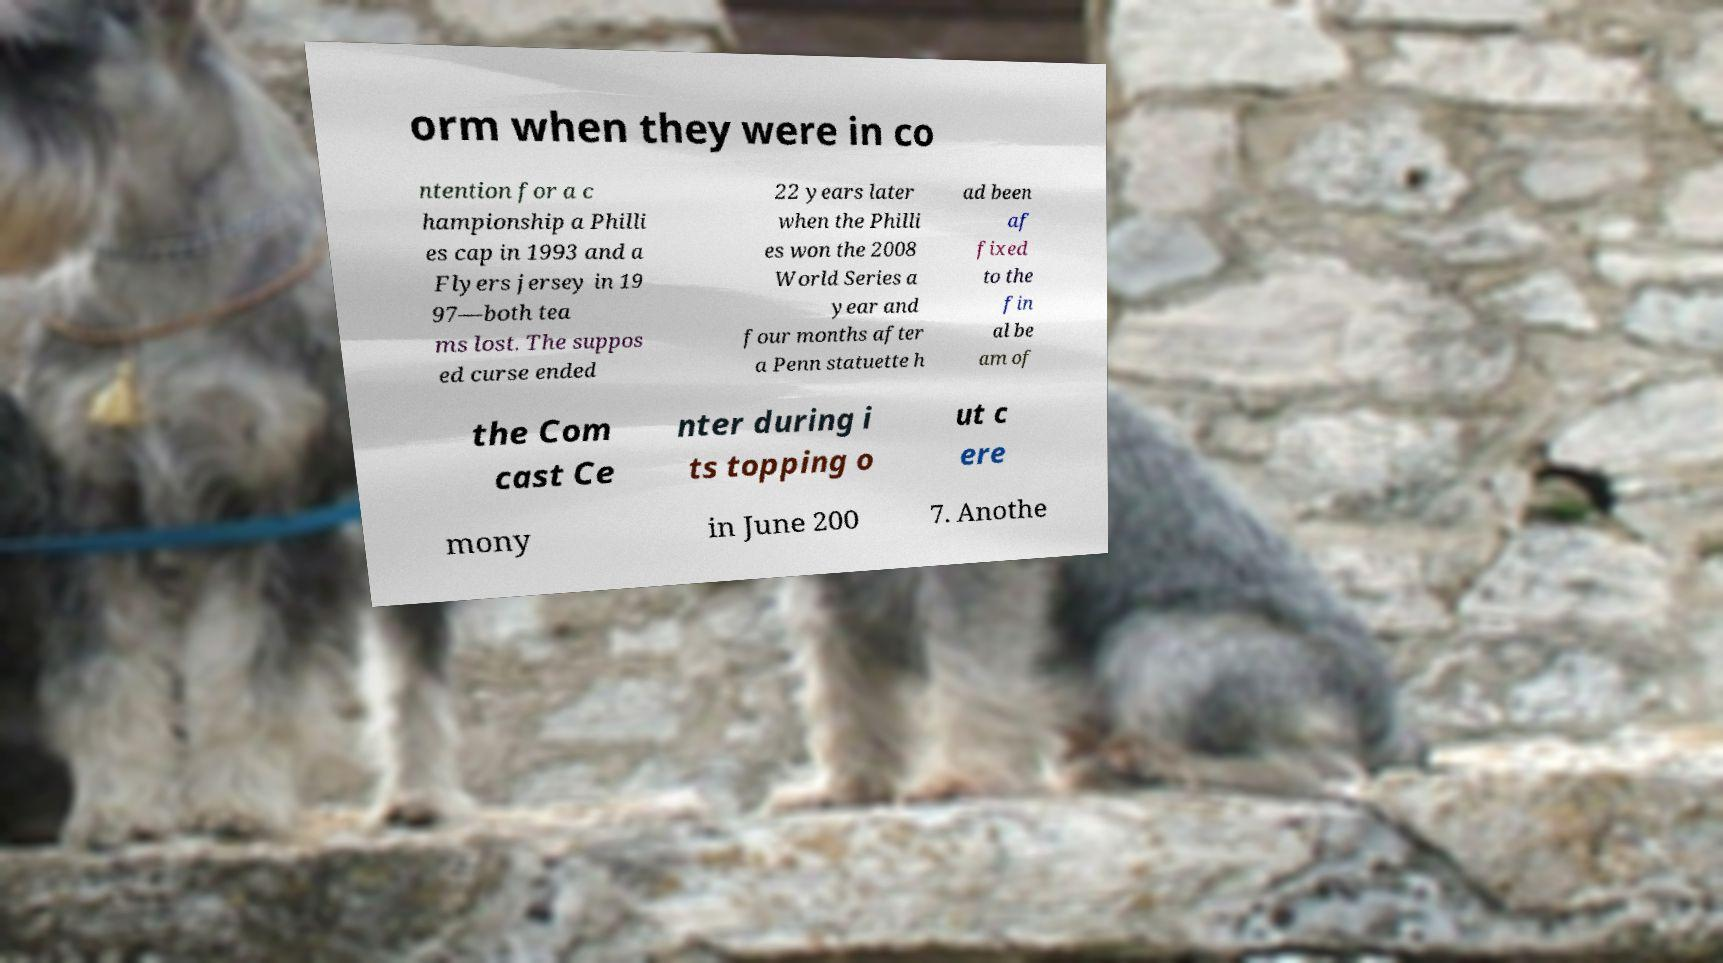Could you assist in decoding the text presented in this image and type it out clearly? orm when they were in co ntention for a c hampionship a Philli es cap in 1993 and a Flyers jersey in 19 97—both tea ms lost. The suppos ed curse ended 22 years later when the Philli es won the 2008 World Series a year and four months after a Penn statuette h ad been af fixed to the fin al be am of the Com cast Ce nter during i ts topping o ut c ere mony in June 200 7. Anothe 